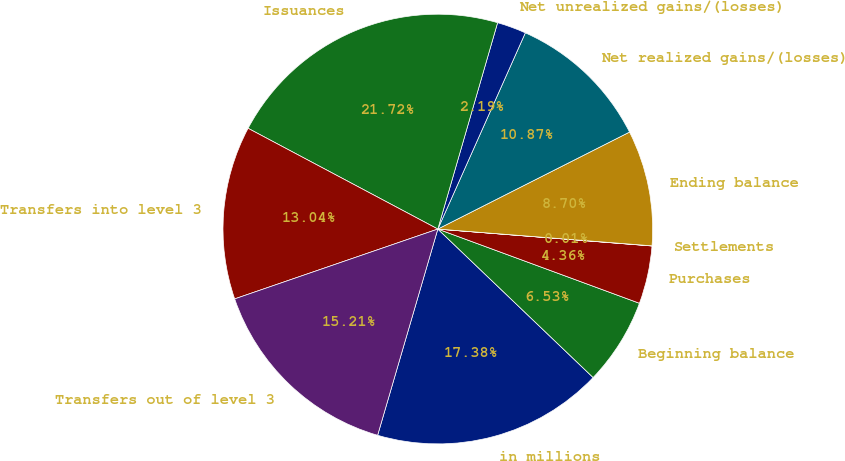Convert chart. <chart><loc_0><loc_0><loc_500><loc_500><pie_chart><fcel>in millions<fcel>Beginning balance<fcel>Purchases<fcel>Settlements<fcel>Ending balance<fcel>Net realized gains/(losses)<fcel>Net unrealized gains/(losses)<fcel>Issuances<fcel>Transfers into level 3<fcel>Transfers out of level 3<nl><fcel>17.38%<fcel>6.53%<fcel>4.36%<fcel>0.01%<fcel>8.7%<fcel>10.87%<fcel>2.19%<fcel>21.72%<fcel>13.04%<fcel>15.21%<nl></chart> 